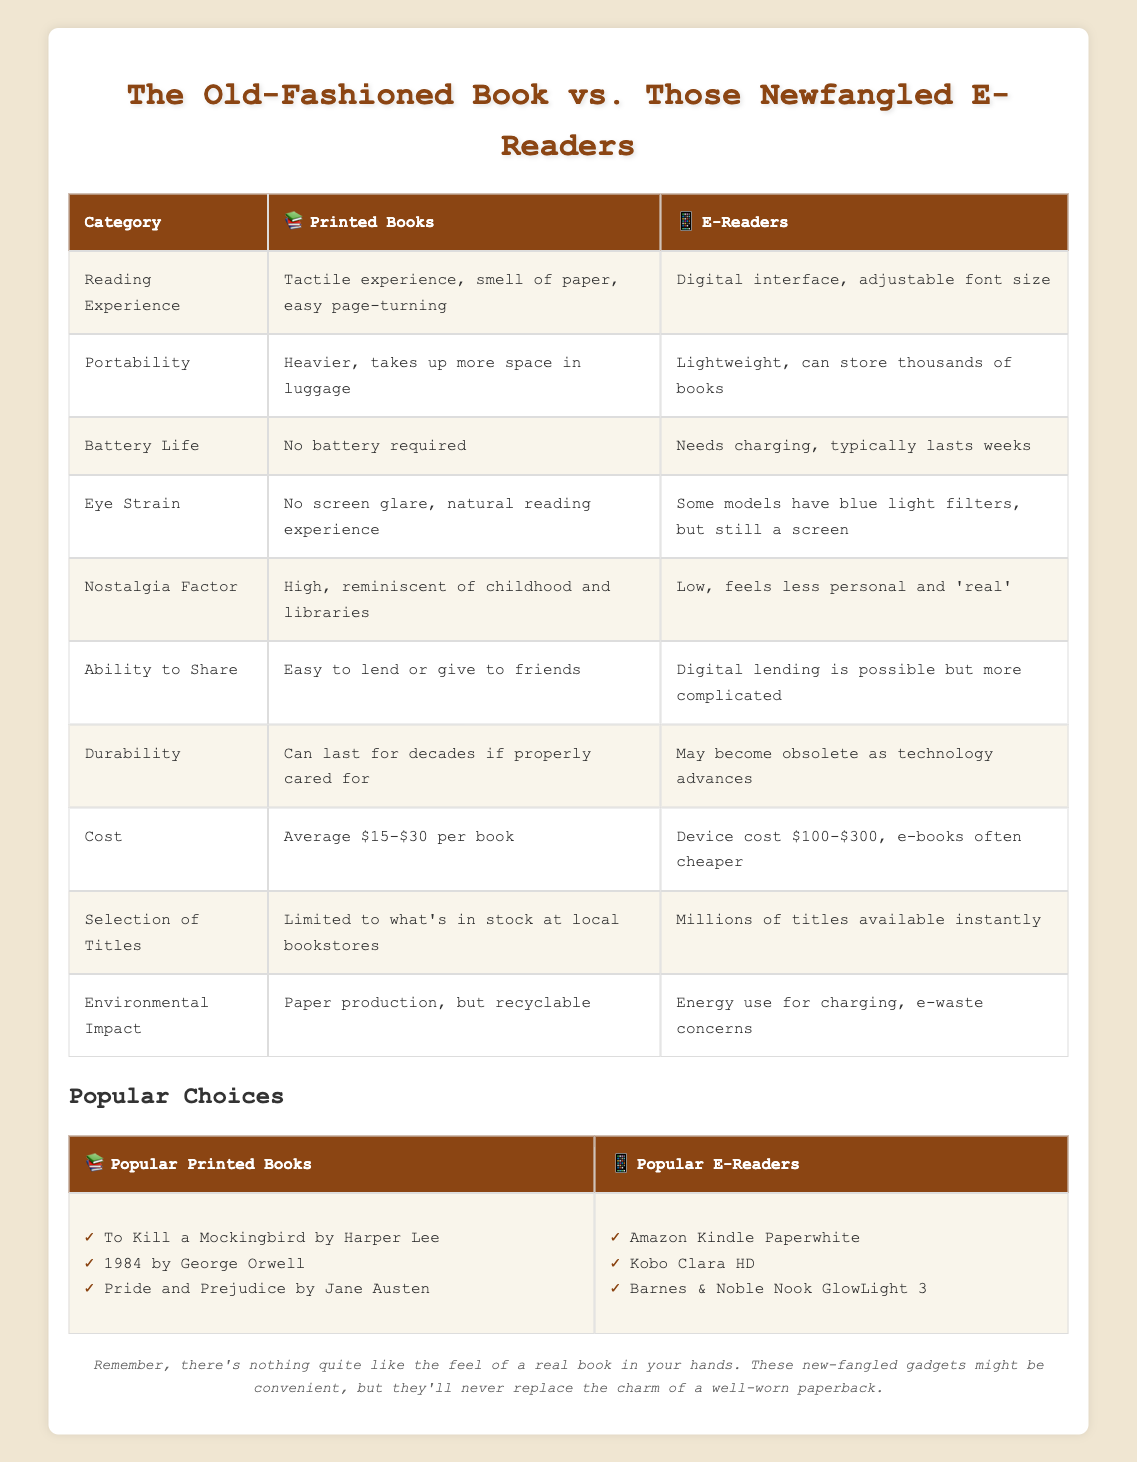What is the reading experience like for printed books? The table states that the reading experience for printed books involves a tactile experience, the smell of paper, and easy page-turning.
Answer: Tactile experience, smell of paper, easy page-turning How do e-readers compare in terms of portability? The table indicates that e-readers are lightweight and can store thousands of books, whereas printed books are heavier and take up more space.
Answer: E-readers are lightweight and store thousands of books Do printed books require a battery? According to the table, printed books do not require a battery, which is a clear fact presented there.
Answer: No Which option is associated with a higher nostalgia factor? The comparison shows that printed books have a high nostalgia factor due to their connection to childhood and libraries, while e-readers have a low nostalgia factor.
Answer: Printed books How much does a printed book typically cost? The table shows that the average cost of a printed book ranges from $15 to $30.
Answer: Average $15-$30 per book Which has a better selection of titles? The table specifies that e-readers have millions of titles available instantly, while printed books are limited to what is in stock at local bookstores.
Answer: E-readers If someone wants to lend a book easily to a friend, which option should they choose? The table states that printed books are easy to lend or give to friends, while digital lending for e-readers is more complicated.
Answer: Printed books What is the environmental impact concern related to e-readers? The table mentions energy use for charging and e-waste concerns as significant environmental impacts for e-readers.
Answer: Energy use for charging, e-waste concerns Is the durability of printed books generally higher than that of e-readers? The table indicates that printed books can last for decades if properly cared for, whereas e-readers may become obsolete with advancing technology.
Answer: Yes 